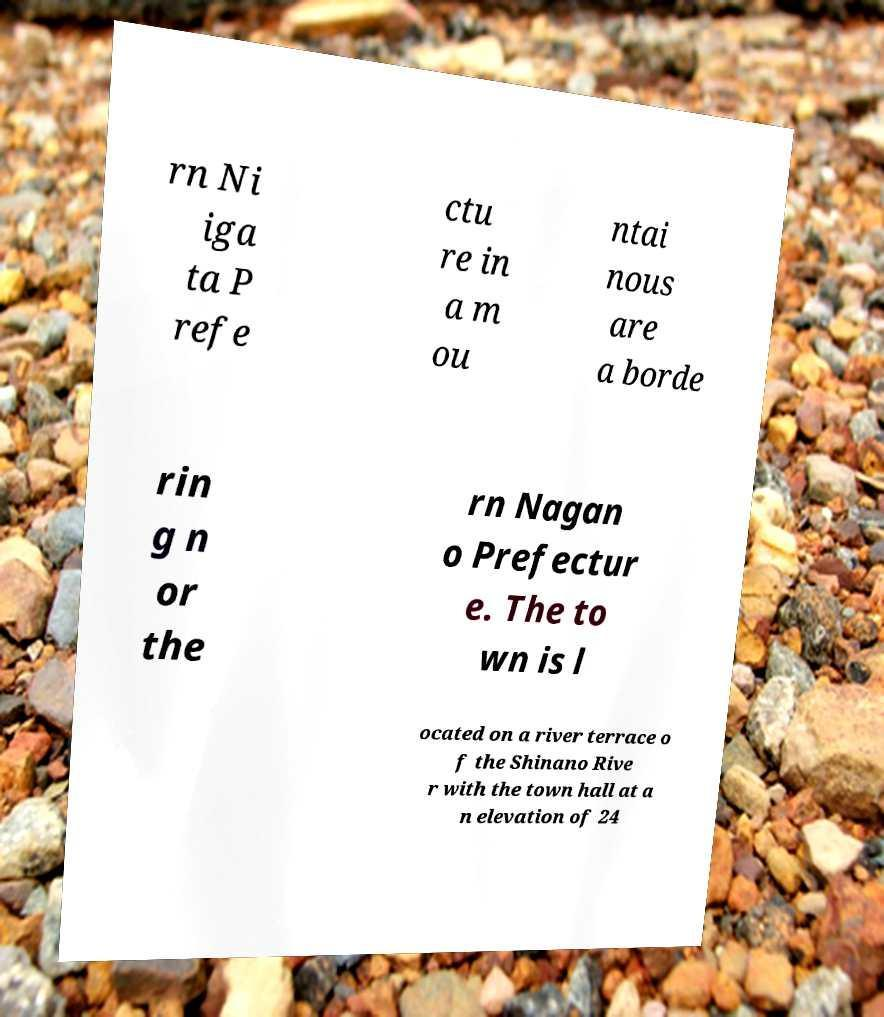Could you assist in decoding the text presented in this image and type it out clearly? rn Ni iga ta P refe ctu re in a m ou ntai nous are a borde rin g n or the rn Nagan o Prefectur e. The to wn is l ocated on a river terrace o f the Shinano Rive r with the town hall at a n elevation of 24 